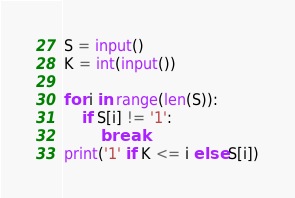Convert code to text. <code><loc_0><loc_0><loc_500><loc_500><_Python_>S = input()
K = int(input())

for i in range(len(S)):
    if S[i] != '1':
        break
print('1' if K <= i else S[i])
</code> 